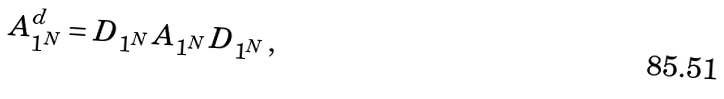<formula> <loc_0><loc_0><loc_500><loc_500>A _ { 1 ^ { N } } ^ { d } = D _ { 1 ^ { N } } \, A _ { 1 ^ { N } } \, D _ { 1 ^ { N } } \, ,</formula> 